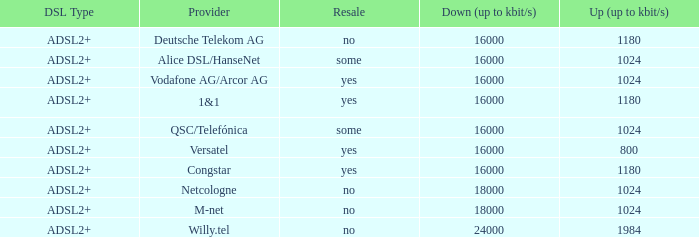How many providers are there where the resale category is yes and bandwith is up is 1024? 1.0. 